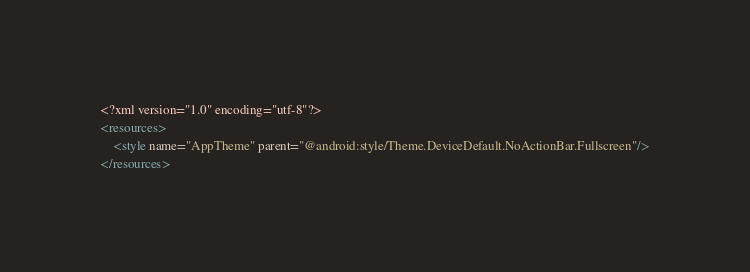<code> <loc_0><loc_0><loc_500><loc_500><_XML_><?xml version="1.0" encoding="utf-8"?>
<resources>
    <style name="AppTheme" parent="@android:style/Theme.DeviceDefault.NoActionBar.Fullscreen"/>
</resources></code> 